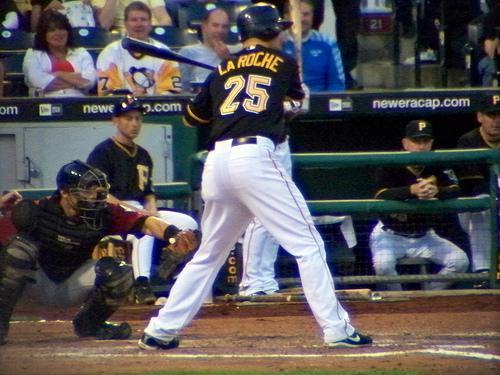How many batters are at the plate?
Give a very brief answer. 1. 